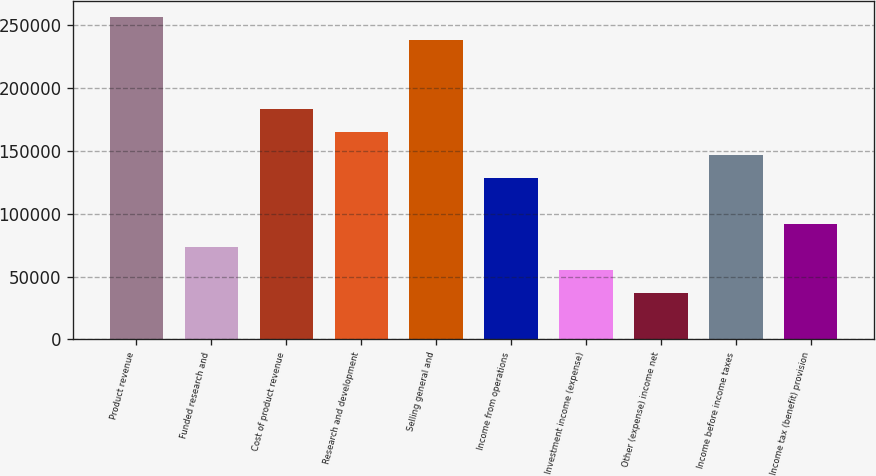Convert chart to OTSL. <chart><loc_0><loc_0><loc_500><loc_500><bar_chart><fcel>Product revenue<fcel>Funded research and<fcel>Cost of product revenue<fcel>Research and development<fcel>Selling general and<fcel>Income from operations<fcel>Investment income (expense)<fcel>Other (expense) income net<fcel>Income before income taxes<fcel>Income tax (benefit) provision<nl><fcel>256592<fcel>73312.1<fcel>183280<fcel>164952<fcel>238264<fcel>128296<fcel>54984.1<fcel>36656.1<fcel>146624<fcel>91640.1<nl></chart> 